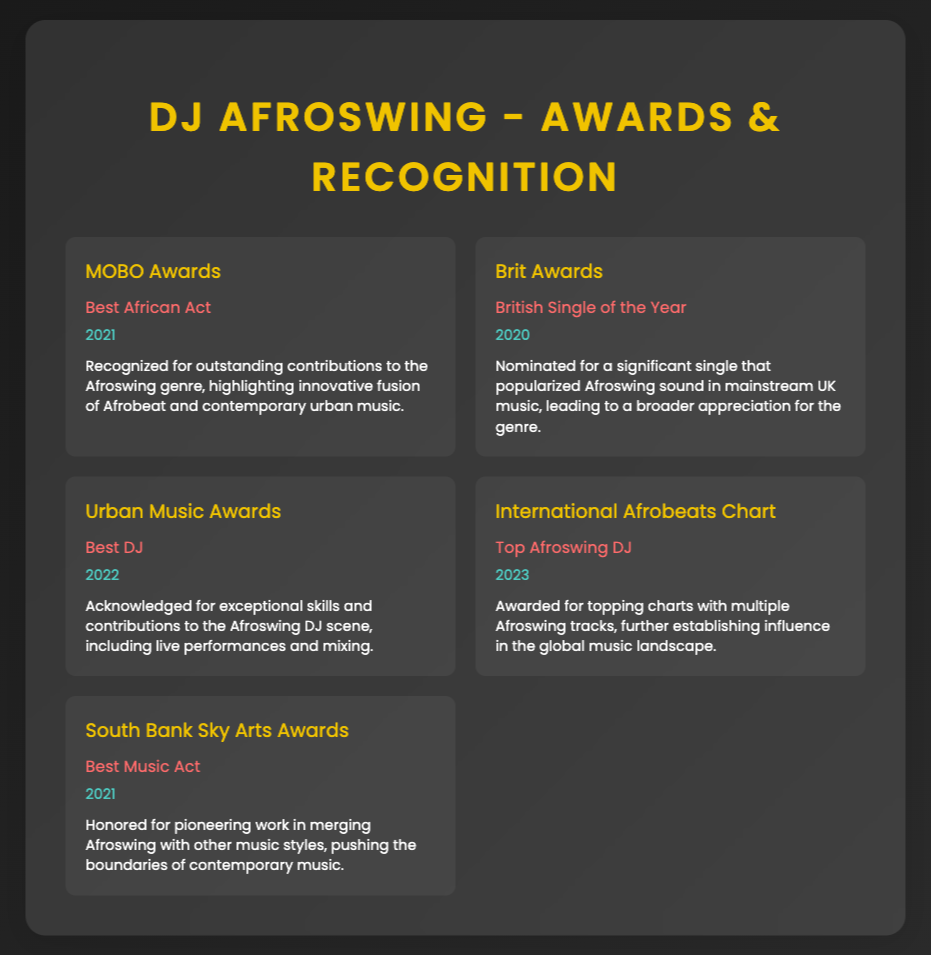What award was won in 2021? The document states that the MOBO Awards were won in 2021 for Best African Act.
Answer: MOBO Awards Which award did you receive for being a DJ in 2022? The Urban Music Awards recognized the contributions in 2022 for Best DJ.
Answer: Best DJ How many awards are listed in total? The document lists a total of five awards in the Awards & Recognition section.
Answer: 5 What category did you get nominated for at the Brit Awards in 2020? The Brit Awards nomination was for British Single of the Year in 2020.
Answer: British Single of the Year What year did you receive the award for Top Afroswing DJ? The award for Top Afroswing DJ was received in 2023.
Answer: 2023 Which award recognized contributions to the fusion of Afrobeat and contemporary urban music? The MOBO Awards recognized outstanding contributions for this fusion.
Answer: MOBO Awards What is the significance of the South Bank Sky Arts Awards in 2021? The award was given for pioneering work in merging Afroswing with other music styles.
Answer: Pioneering work in merging Afroswing Which award highlights the popularization of Afroswing in mainstream UK music? The Brit Awards highlighted this significance with the nomination for British Single of the Year.
Answer: Brit Awards 